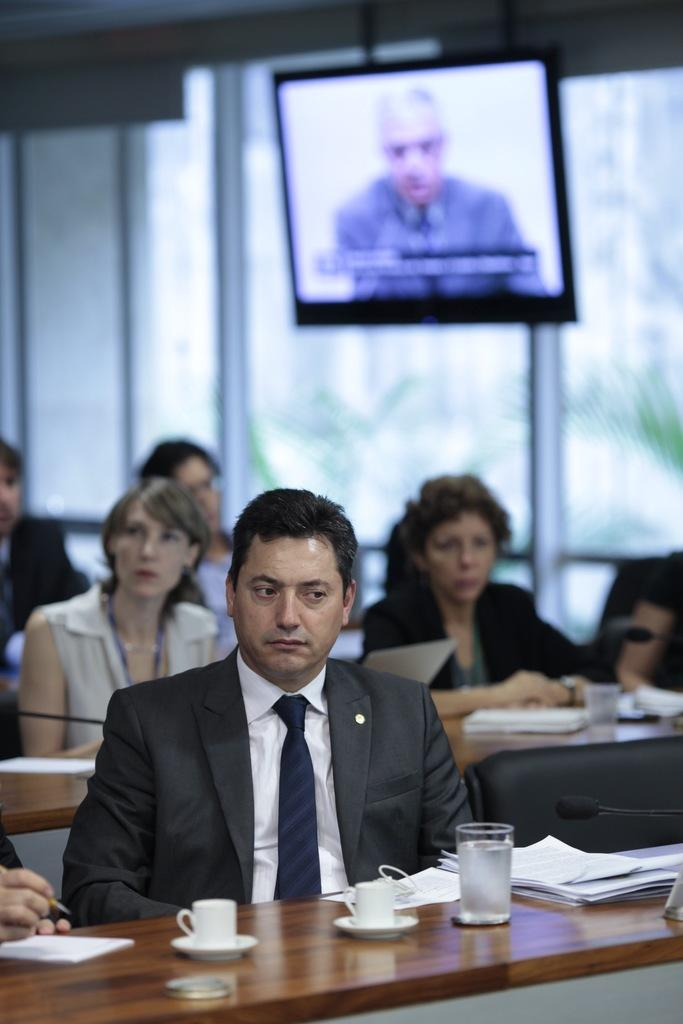What is the man in the image doing? The man is seated on a chair in the image. What is in front of the man? The man is in front of a table. What can be seen on the table? There are two teacups and a glass on the table. Are there any other people in the image? Yes, there are people seated nearby. What is on top of something in the image? There is a television on top of something, possibly a cabinet or another table. What type of road can be seen in the image? There is no road visible in the image. Can you solve the riddle written on the table in the image? There is no riddle written on the table in the image. 